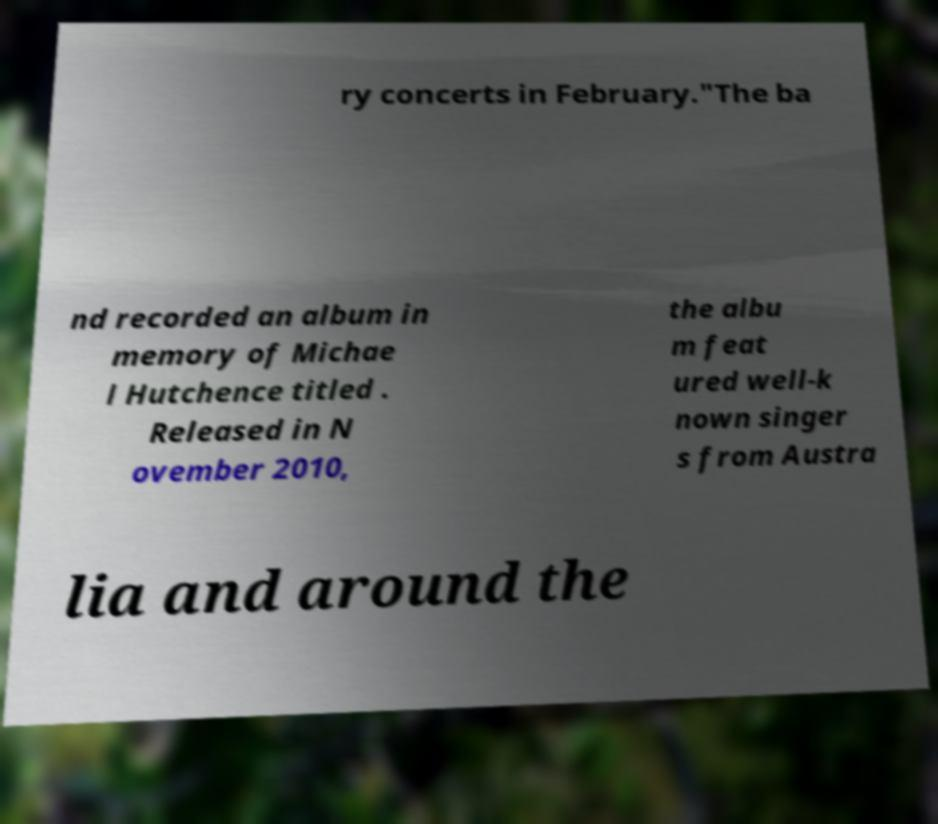There's text embedded in this image that I need extracted. Can you transcribe it verbatim? ry concerts in February."The ba nd recorded an album in memory of Michae l Hutchence titled . Released in N ovember 2010, the albu m feat ured well-k nown singer s from Austra lia and around the 